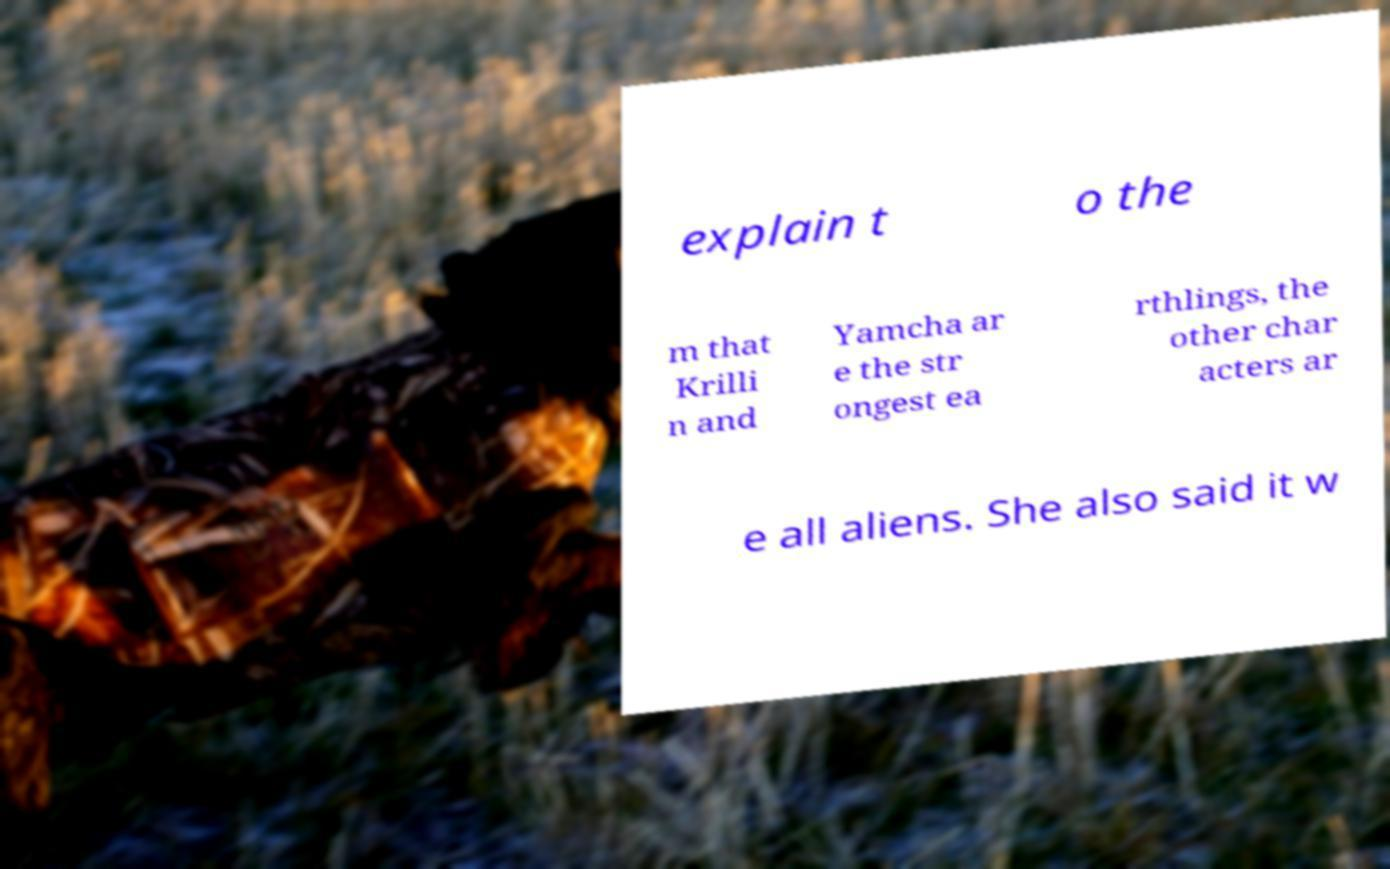Please read and relay the text visible in this image. What does it say? explain t o the m that Krilli n and Yamcha ar e the str ongest ea rthlings, the other char acters ar e all aliens. She also said it w 